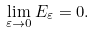<formula> <loc_0><loc_0><loc_500><loc_500>\lim _ { \varepsilon \rightarrow 0 } E _ { \varepsilon } = 0 .</formula> 